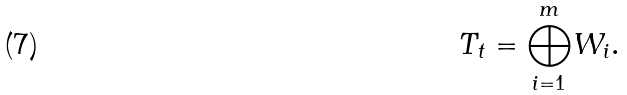Convert formula to latex. <formula><loc_0><loc_0><loc_500><loc_500>T _ { t } = { \bigoplus ^ { m } _ { i = 1 } } W _ { i } .</formula> 